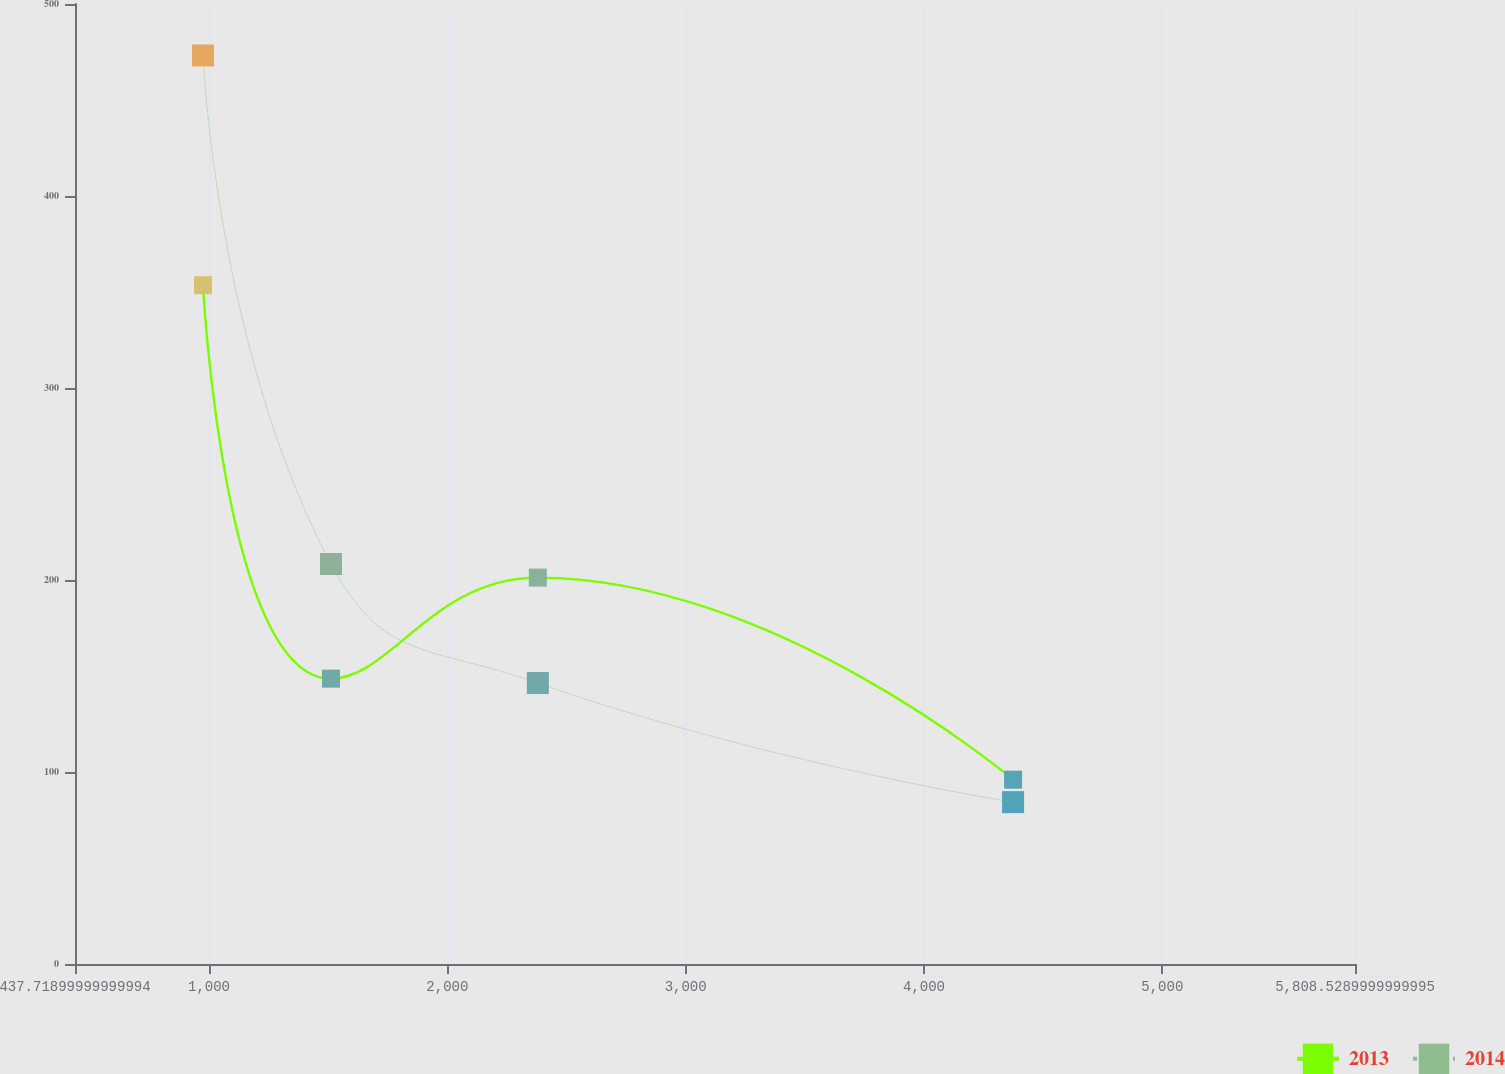Convert chart. <chart><loc_0><loc_0><loc_500><loc_500><line_chart><ecel><fcel>2013<fcel>2014<nl><fcel>974.8<fcel>353.53<fcel>473.18<nl><fcel>1511.88<fcel>148.62<fcel>208.34<nl><fcel>2379.73<fcel>201.25<fcel>146.32<nl><fcel>4373.91<fcel>96<fcel>84.3<nl><fcel>6345.61<fcel>622.25<fcel>704.53<nl></chart> 